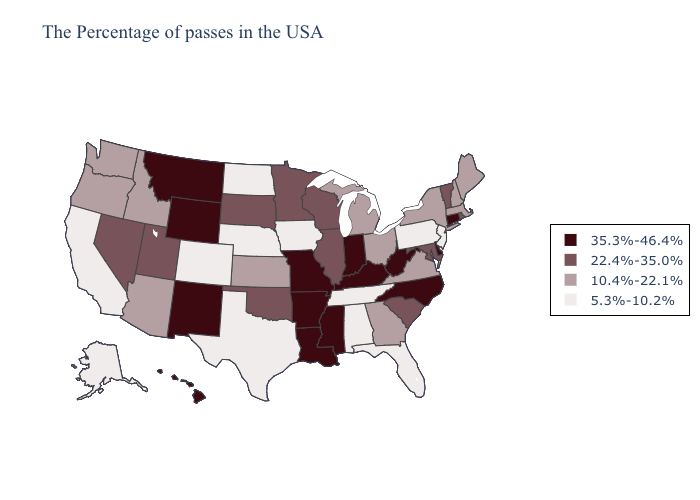Which states have the highest value in the USA?
Concise answer only. Connecticut, Delaware, North Carolina, West Virginia, Kentucky, Indiana, Mississippi, Louisiana, Missouri, Arkansas, Wyoming, New Mexico, Montana, Hawaii. Does Vermont have the highest value in the Northeast?
Quick response, please. No. Does Hawaii have a higher value than Mississippi?
Write a very short answer. No. Name the states that have a value in the range 5.3%-10.2%?
Write a very short answer. New Jersey, Pennsylvania, Florida, Alabama, Tennessee, Iowa, Nebraska, Texas, North Dakota, Colorado, California, Alaska. What is the lowest value in the West?
Write a very short answer. 5.3%-10.2%. Which states have the lowest value in the South?
Quick response, please. Florida, Alabama, Tennessee, Texas. Name the states that have a value in the range 10.4%-22.1%?
Keep it brief. Maine, Massachusetts, New Hampshire, New York, Virginia, Ohio, Georgia, Michigan, Kansas, Arizona, Idaho, Washington, Oregon. What is the value of North Carolina?
Give a very brief answer. 35.3%-46.4%. Does the map have missing data?
Concise answer only. No. What is the lowest value in states that border Nevada?
Write a very short answer. 5.3%-10.2%. Does the first symbol in the legend represent the smallest category?
Answer briefly. No. Does Mississippi have the lowest value in the South?
Be succinct. No. Name the states that have a value in the range 10.4%-22.1%?
Short answer required. Maine, Massachusetts, New Hampshire, New York, Virginia, Ohio, Georgia, Michigan, Kansas, Arizona, Idaho, Washington, Oregon. What is the highest value in the USA?
Short answer required. 35.3%-46.4%. 